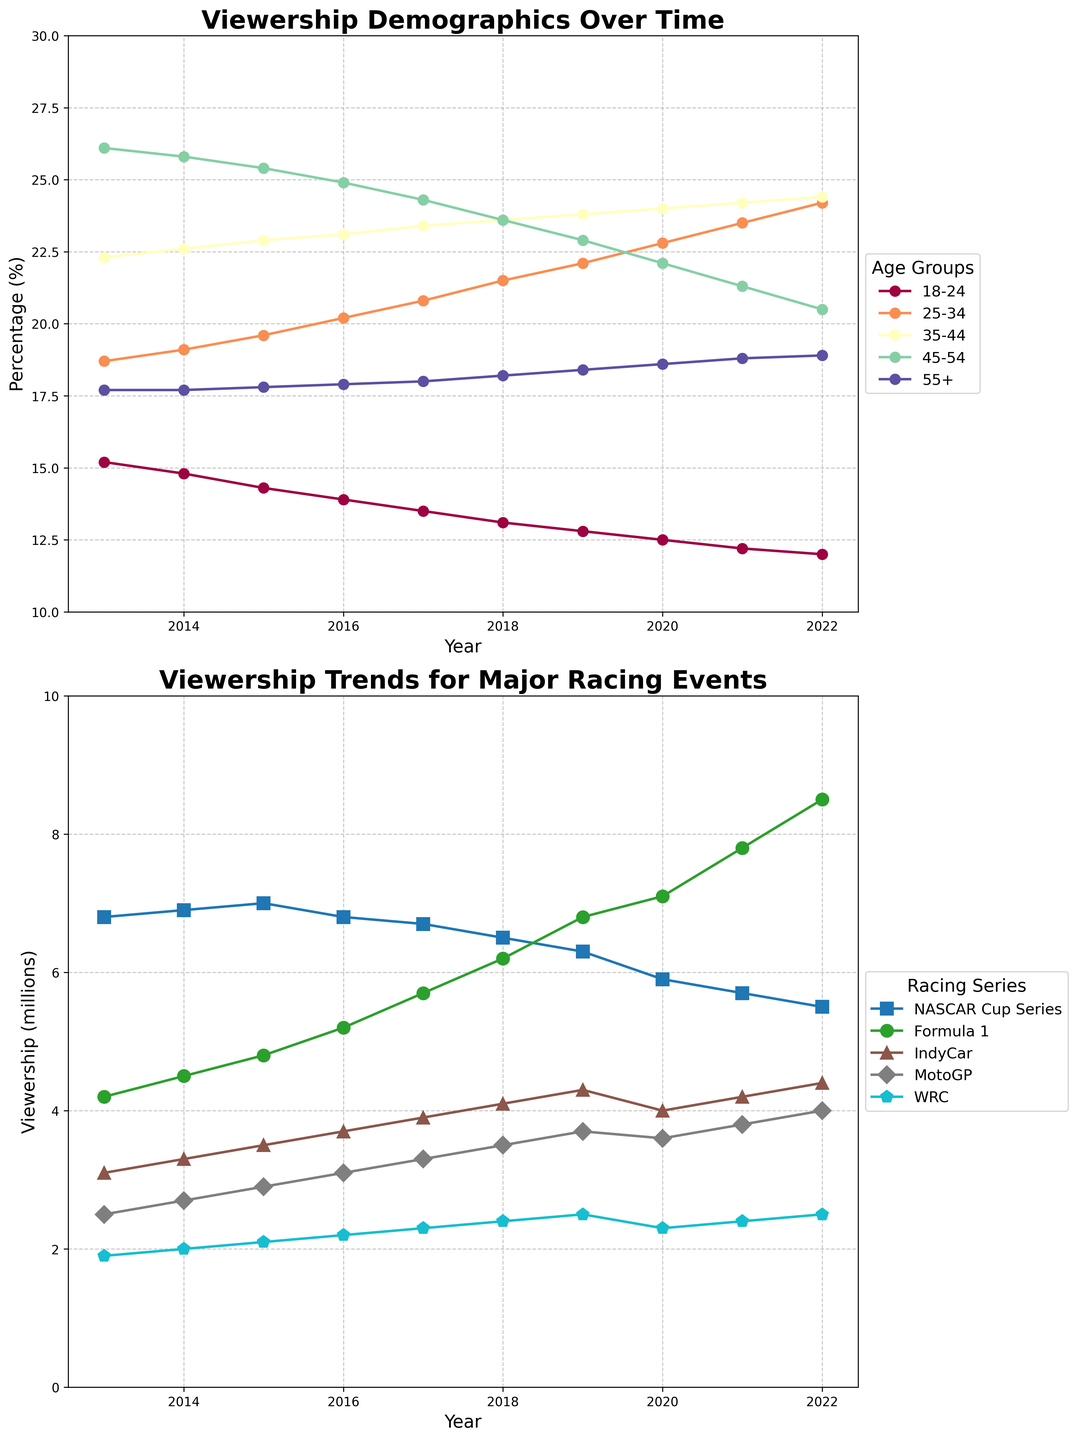What's the trend of viewership among the 25-34 demographic over the past decade? To identify the trend for the 25-34 age group, follow the line labeled '25-34' from 2013 to 2022. It shows an increasing trend as the values rise from 18.7% in 2013 to 24.2% in 2022.
Answer: Increasing trend Which racing series had the highest viewership in 2022? To find the highest viewership in 2022, look at the values for the different racing series for the year 2022. Formula 1 leads with 8.5 million viewers.
Answer: Formula 1 What is the difference in viewership percentages between the 45-54 and 55+ age groups in 2016? Check the values for the 45-54 and 55+ age groups in 2016. The 45-54 age group is at 24.9%, while the 55+ age group is at 17.9%. The difference is 24.9% - 17.9% = 7%.
Answer: 7% How does the viewership of MotoGP in 2022 compare to that in 2013? Compare the values for MotoGP in 2022 and 2013. In 2013, it was 2.5 million and in 2022 it is 4.0 million. So, the viewership increased by 1.5 million.
Answer: Increased by 1.5 million Which demographic group consistently had the lowest percentage viewership over the past decade? Identify the group with the lowest percentage in each year. The 18-24 age group has the lowest values across all years from 2013 to 2022.
Answer: 18-24 What is the average viewership for the NASCAR Cup Series over the decade? Calculate the average by adding the viewership numbers for NASCAR from 2013 to 2022 and then dividing by the number of years (10). The values are 6.8, 6.9, 7.0, 6.8, 6.7, 6.5, 6.3, 5.9, 5.7, 5.5. Sum = 64.1. The average is 64.1 / 10 = 6.41 million.
Answer: 6.41 million Which demographic group saw the biggest change in viewership percentage from 2013 to 2022? Compare the changes in percentages for each demographic group between 2013 and 2022. The 25-34 group increased from 18.7% to 24.2%, a change of 5.5%, which is the largest increase.
Answer: 25-34 What pattern do you observe in the viewership trend of IndyCar from 2016 to 2021? Examine the line for IndyCar from 2016 to 2021. The viewership steadily decreased from 3.7 million in 2016 to 4.2 million in 2021. The pattern indicates a relatively steady increase.
Answer: Steady increase Which year marks the start of the increase in viewership for Formula 1? Look at the viewership trend for Formula 1. It starts increasing notably from 2016 onwards, where the values rise year over year from 2016 to 2022.
Answer: 2016 Is the viewership of any racing series decreasing over the years? Check the lines for each racing series. NASCAR Cup Series shows a steady decrease from 6.8 million in 2013 to 5.5 million in 2022.
Answer: NASCAR Cup Series 